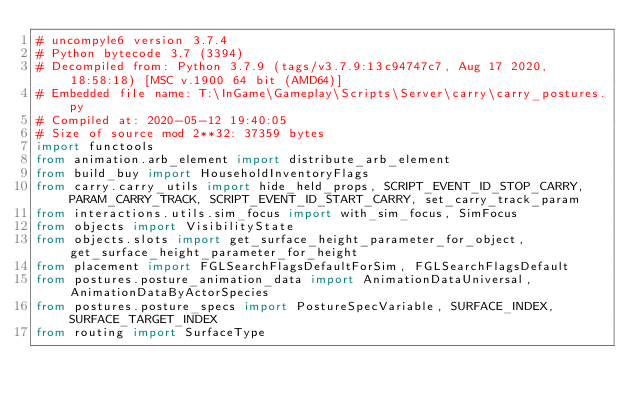<code> <loc_0><loc_0><loc_500><loc_500><_Python_># uncompyle6 version 3.7.4
# Python bytecode 3.7 (3394)
# Decompiled from: Python 3.7.9 (tags/v3.7.9:13c94747c7, Aug 17 2020, 18:58:18) [MSC v.1900 64 bit (AMD64)]
# Embedded file name: T:\InGame\Gameplay\Scripts\Server\carry\carry_postures.py
# Compiled at: 2020-05-12 19:40:05
# Size of source mod 2**32: 37359 bytes
import functools
from animation.arb_element import distribute_arb_element
from build_buy import HouseholdInventoryFlags
from carry.carry_utils import hide_held_props, SCRIPT_EVENT_ID_STOP_CARRY, PARAM_CARRY_TRACK, SCRIPT_EVENT_ID_START_CARRY, set_carry_track_param
from interactions.utils.sim_focus import with_sim_focus, SimFocus
from objects import VisibilityState
from objects.slots import get_surface_height_parameter_for_object, get_surface_height_parameter_for_height
from placement import FGLSearchFlagsDefaultForSim, FGLSearchFlagsDefault
from postures.posture_animation_data import AnimationDataUniversal, AnimationDataByActorSpecies
from postures.posture_specs import PostureSpecVariable, SURFACE_INDEX, SURFACE_TARGET_INDEX
from routing import SurfaceType</code> 